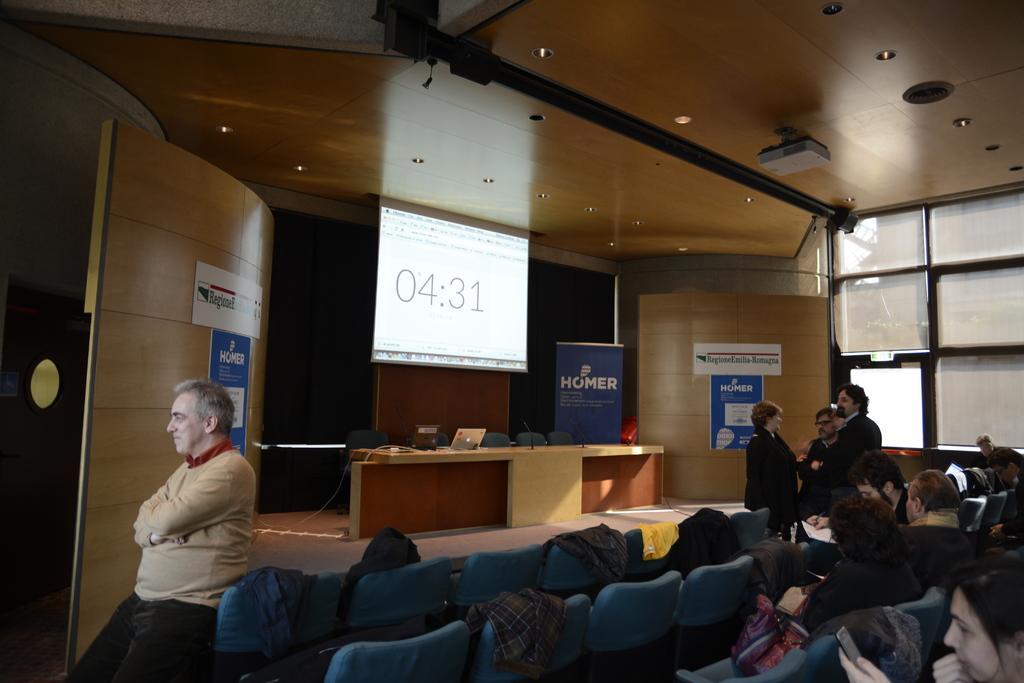Can you describe this image briefly? In this picture there is a man standing here and three of them are talking in the background. We can observe some people sitting in the chairs. In front of them there is a table and some chairs. On the table there are some laptops and microphone here. We can observe projector display screen here. 